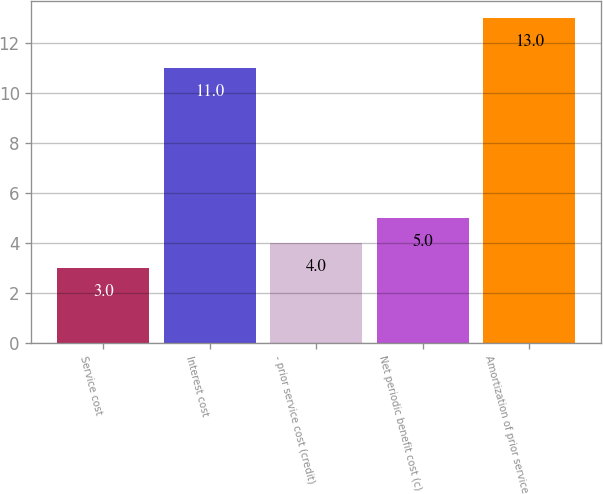Convert chart. <chart><loc_0><loc_0><loc_500><loc_500><bar_chart><fcel>Service cost<fcel>Interest cost<fcel>- prior service cost (credit)<fcel>Net periodic benefit cost (c)<fcel>Amortization of prior service<nl><fcel>3<fcel>11<fcel>4<fcel>5<fcel>13<nl></chart> 